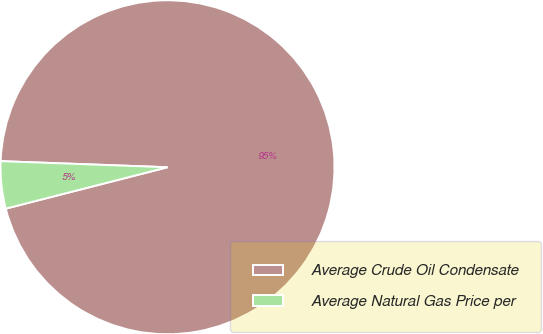Convert chart. <chart><loc_0><loc_0><loc_500><loc_500><pie_chart><fcel>Average Crude Oil Condensate<fcel>Average Natural Gas Price per<nl><fcel>95.43%<fcel>4.57%<nl></chart> 